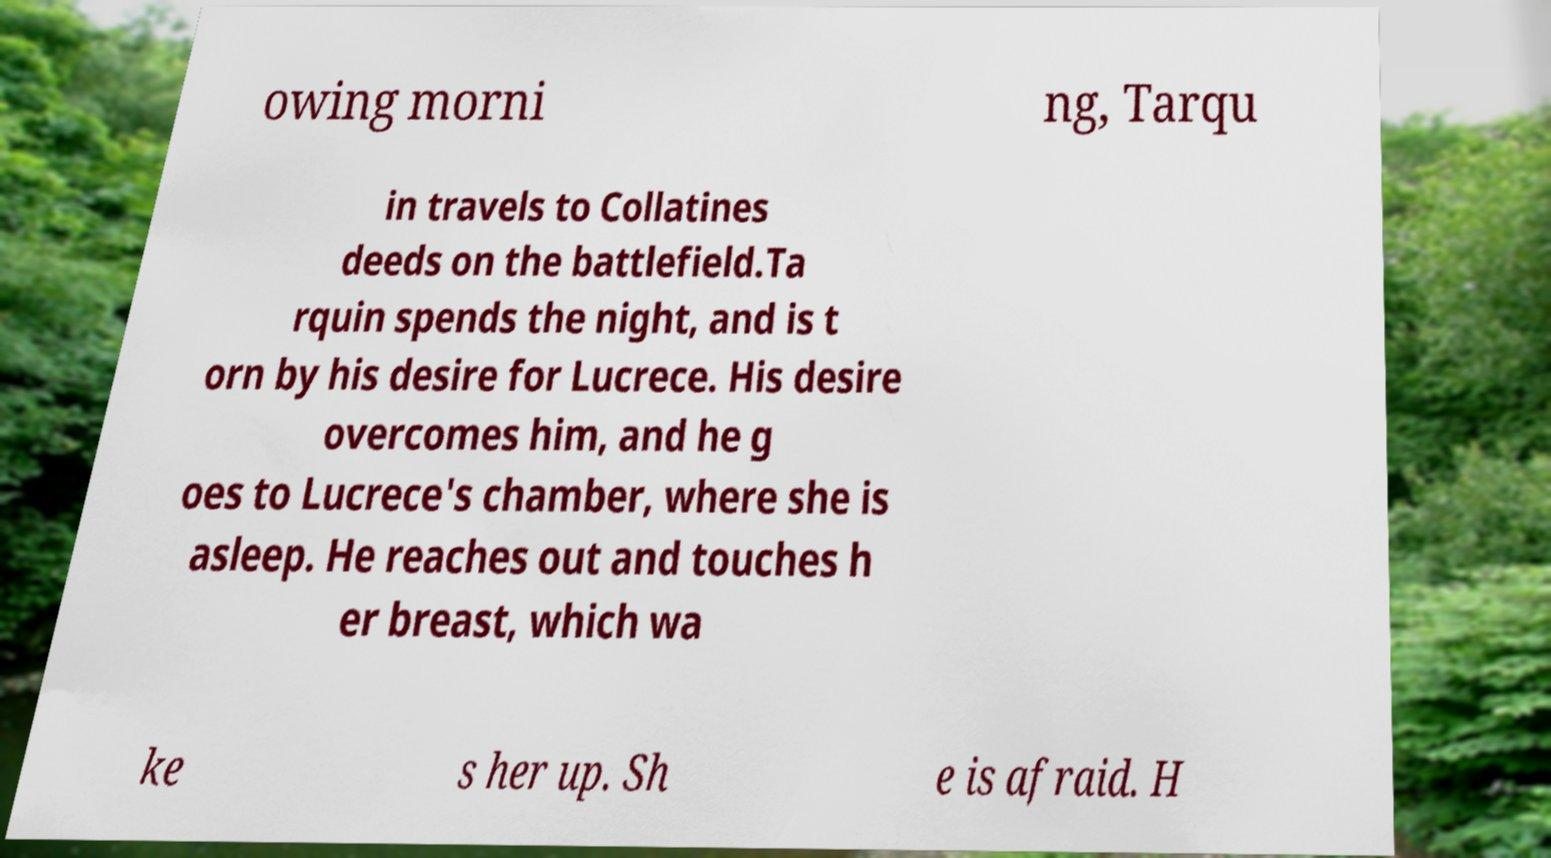Please read and relay the text visible in this image. What does it say? owing morni ng, Tarqu in travels to Collatines deeds on the battlefield.Ta rquin spends the night, and is t orn by his desire for Lucrece. His desire overcomes him, and he g oes to Lucrece's chamber, where she is asleep. He reaches out and touches h er breast, which wa ke s her up. Sh e is afraid. H 